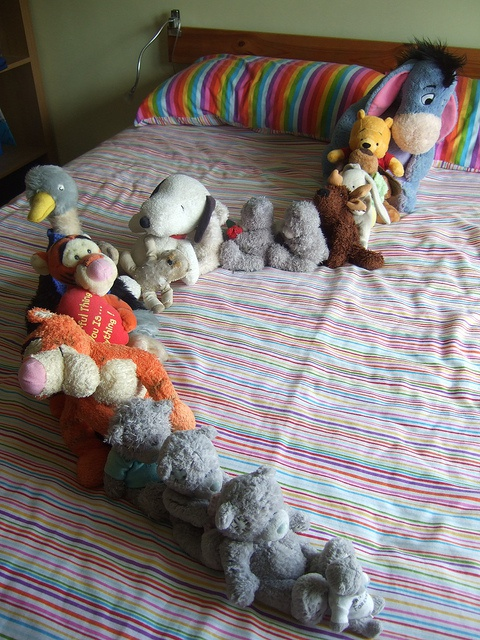Describe the objects in this image and their specific colors. I can see bed in black, lightgray, gray, and darkgray tones, teddy bear in black, gray, and darkgray tones, teddy bear in black, gray, darkgray, and lightgray tones, teddy bear in black, gray, darkgray, and purple tones, and teddy bear in black, darkgray, gray, and lightgray tones in this image. 